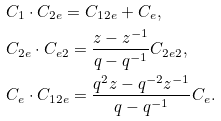Convert formula to latex. <formula><loc_0><loc_0><loc_500><loc_500>& C _ { 1 } \cdot C _ { 2 e } = C _ { 1 2 e } + C _ { e } , \\ & C _ { 2 e } \cdot C _ { e 2 } = \frac { z - z ^ { - 1 } } { q - q ^ { - 1 } } C _ { 2 e 2 } , \\ & C _ { e } \cdot C _ { 1 2 e } = \frac { q ^ { 2 } z - q ^ { - 2 } z ^ { - 1 } } { q - q ^ { - 1 } } C _ { e } .</formula> 